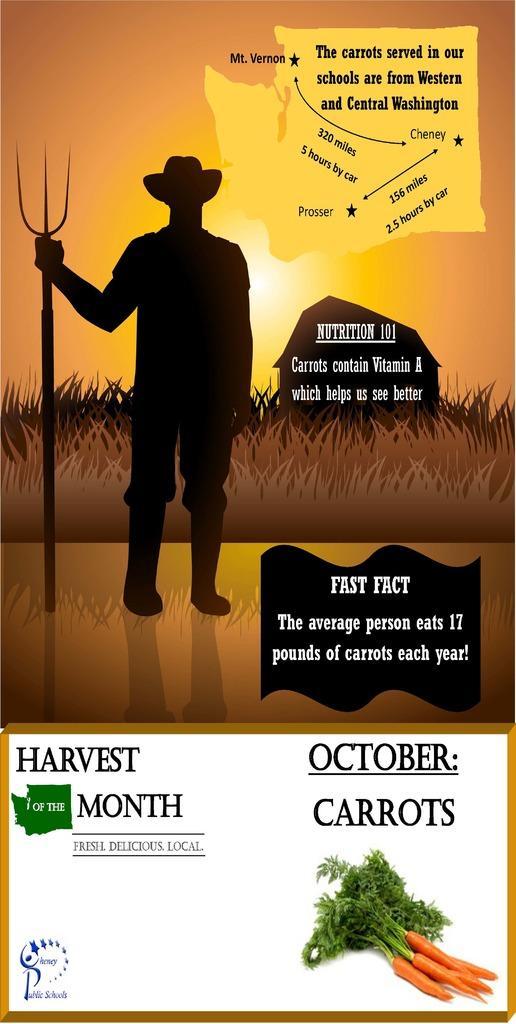Can you describe this image briefly? In this picture I can see there is a man standing and he is holding a tool in his right hand and there is grass in the backdrop and this is a animated image and at the bottom of the image there are carrots and a logo onto left side. There is something written on image. 